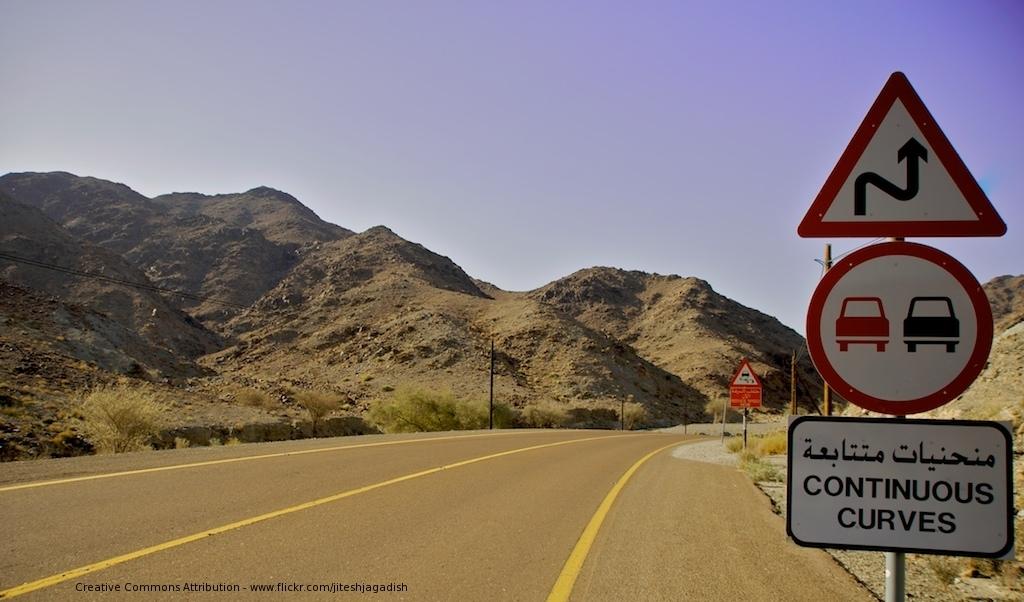What is continuous?
Make the answer very short. Curves. What does the bottom sign say?
Give a very brief answer. Continuous curves. 